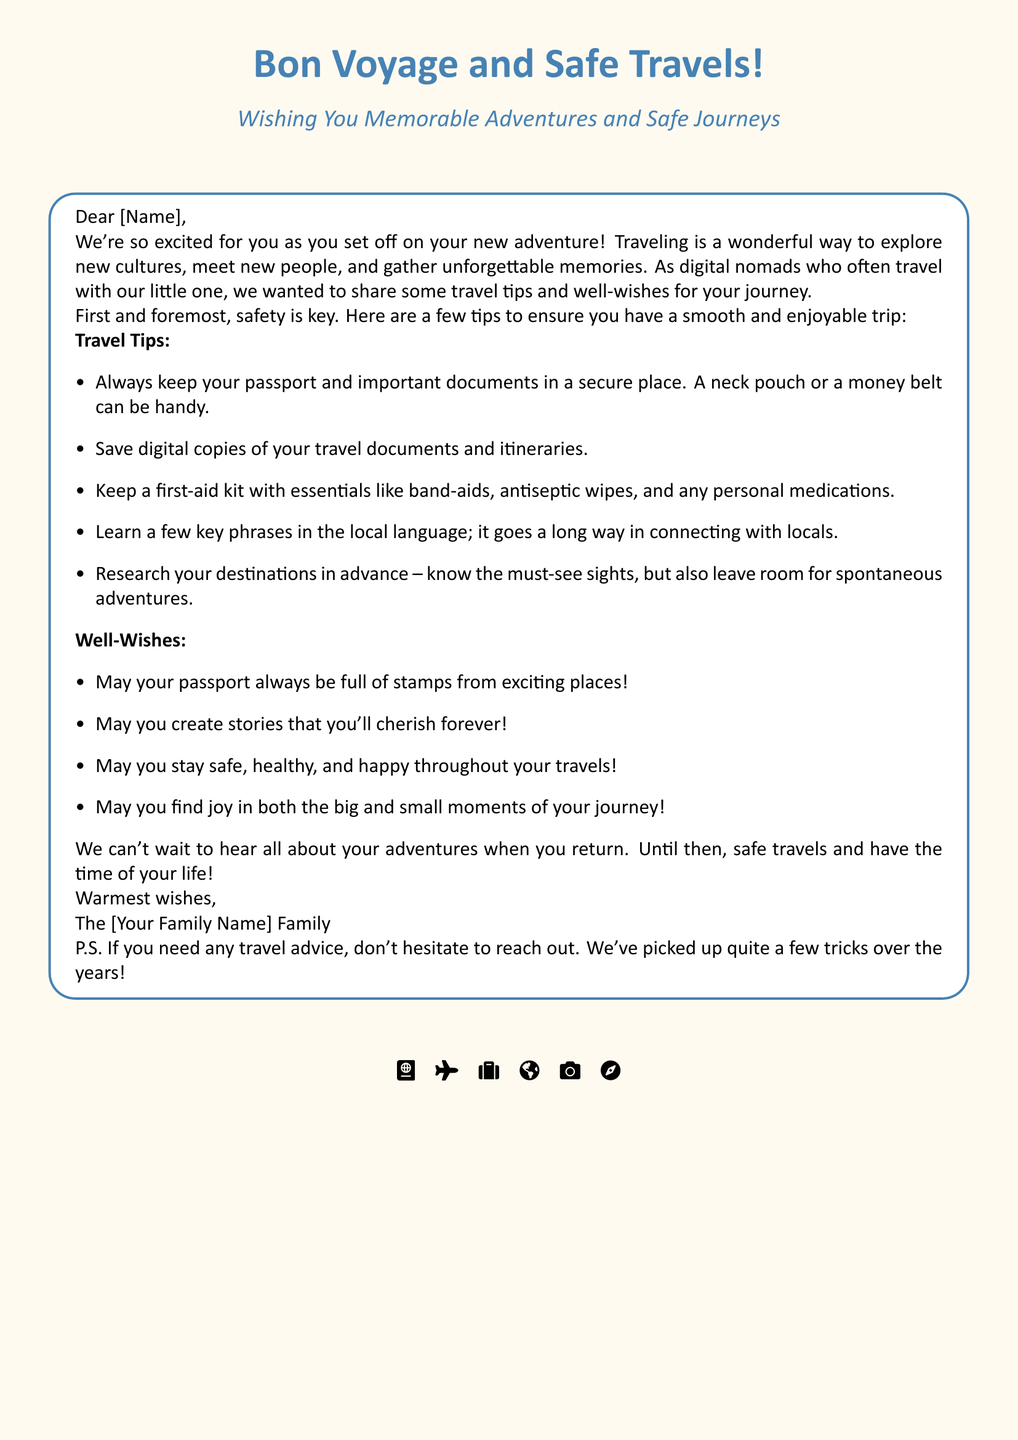What is the card's main title? The main title is prominently displayed at the top of the card, emphasizing the theme of the card.
Answer: Bon Voyage and Safe Travels! What color is used for the header? The document specifies a specific color type for the header throughout the card for visual appeal.
Answer: Header Color Who is the card addressed to? The card is personalized with a space for the recipient's name, which is indicated in the greeting.
Answer: [Name] What type of tips are included in the card? The card includes a specific category of tips to enhance the travel experience for the recipient.
Answer: Travel Tips What is one item suggested to keep personal documents secure? The card provides practical advice on securing travel documents and suggests a particular item for safety.
Answer: Money belt Which family is sending the card? The card ends with a warm signature indicating who the well-wishes are from.
Answer: The [Your Family Name] Family What is one well-wish mentioned in the card? The card includes specific well-wishes for the traveler, highlighting positive outcomes.
Answer: May your passport always be full of stamps from exciting places! What symbols are included at the bottom of the card? The document features travel-themed icons, which visually enhance the card's theme at the bottom.
Answer: Passport, Plane, Suitcase, Globe, Camera, Compass 